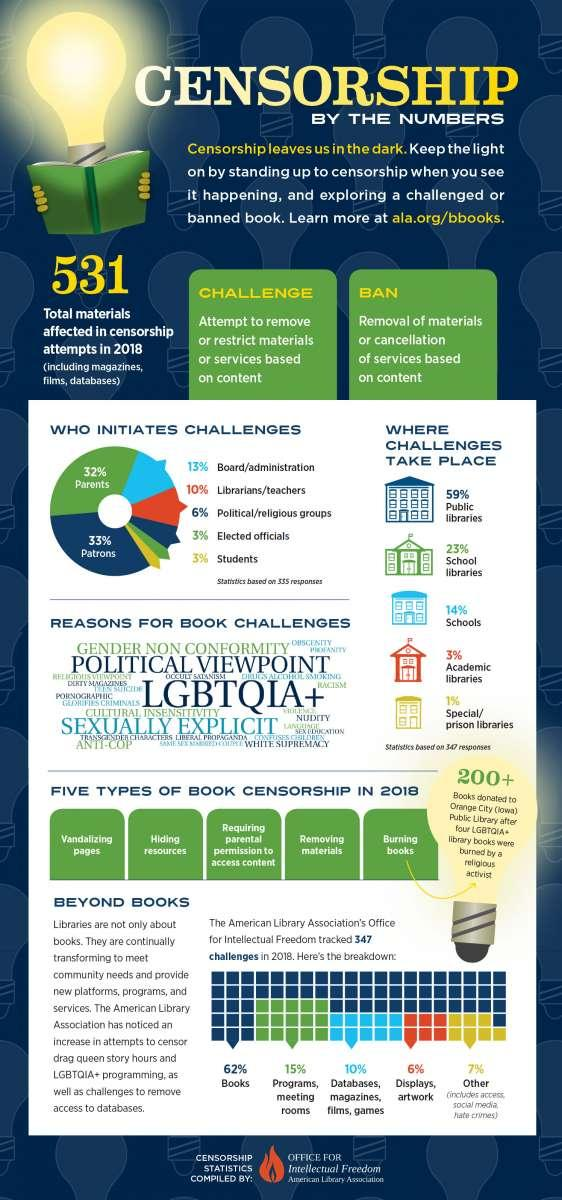Point out several critical features in this image. According to the American Library Association's statistics from 2018, a total of 3,460 books were challenged, accounting for a staggering 62% of the total number of challenges reported that year. According to the statistics of the American Library Association, the majority of challenges take place in public libraries. Patrons are the group that contributes the most in initiating a challenge in statistics from the American Library Association. According to the statistics of the American Library Association, 6% of the challenges facing libraries in the United States are initiated by political or religious groups. In 2018, a total of 531 materials were affected by censorship attempts. 